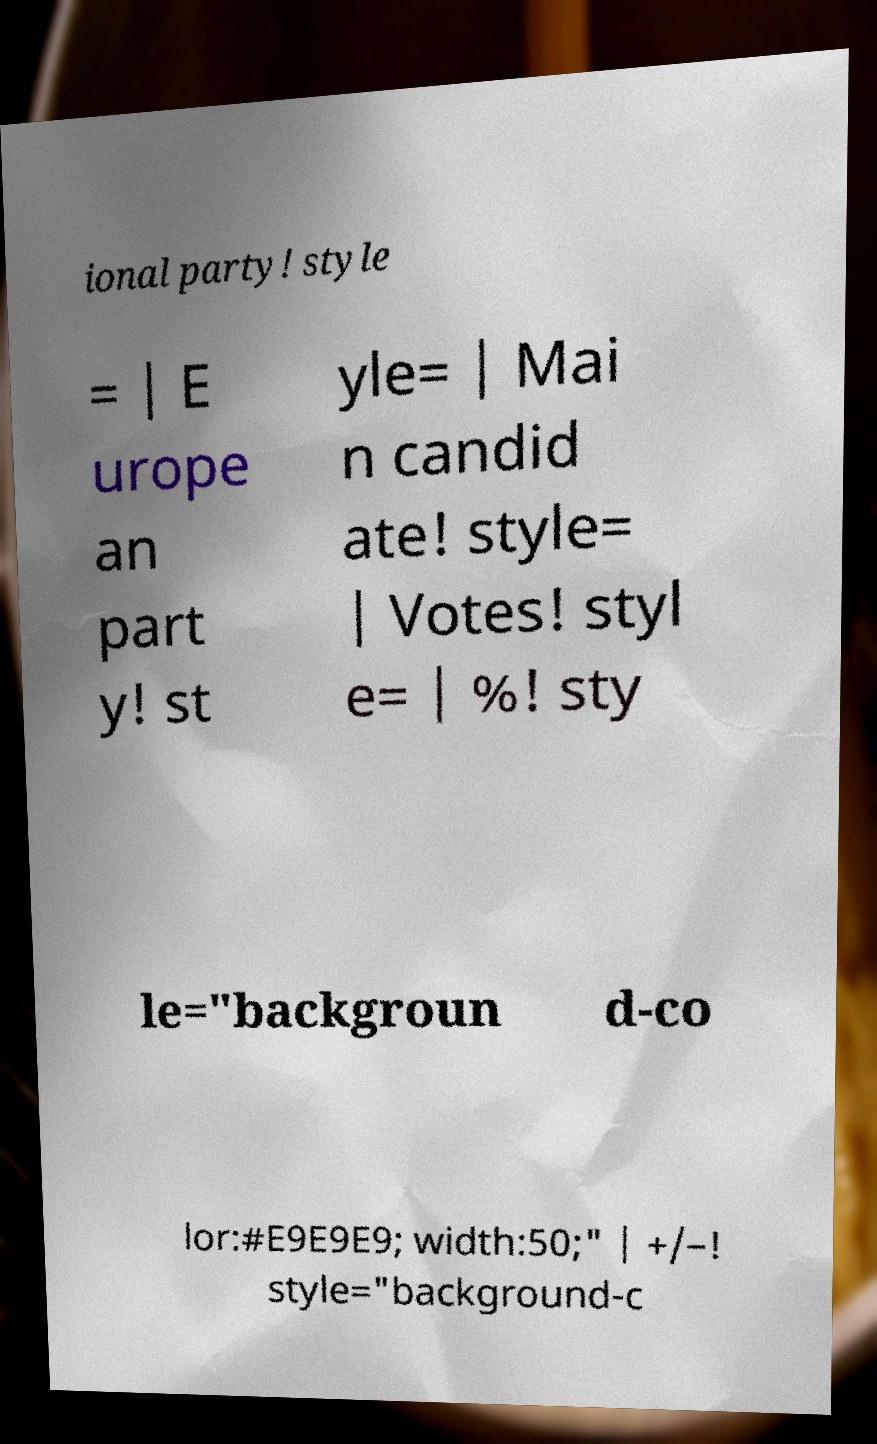Can you read and provide the text displayed in the image?This photo seems to have some interesting text. Can you extract and type it out for me? ional party! style = | E urope an part y! st yle= | Mai n candid ate! style= | Votes! styl e= | %! sty le="backgroun d-co lor:#E9E9E9; width:50;" | +/–! style="background-c 